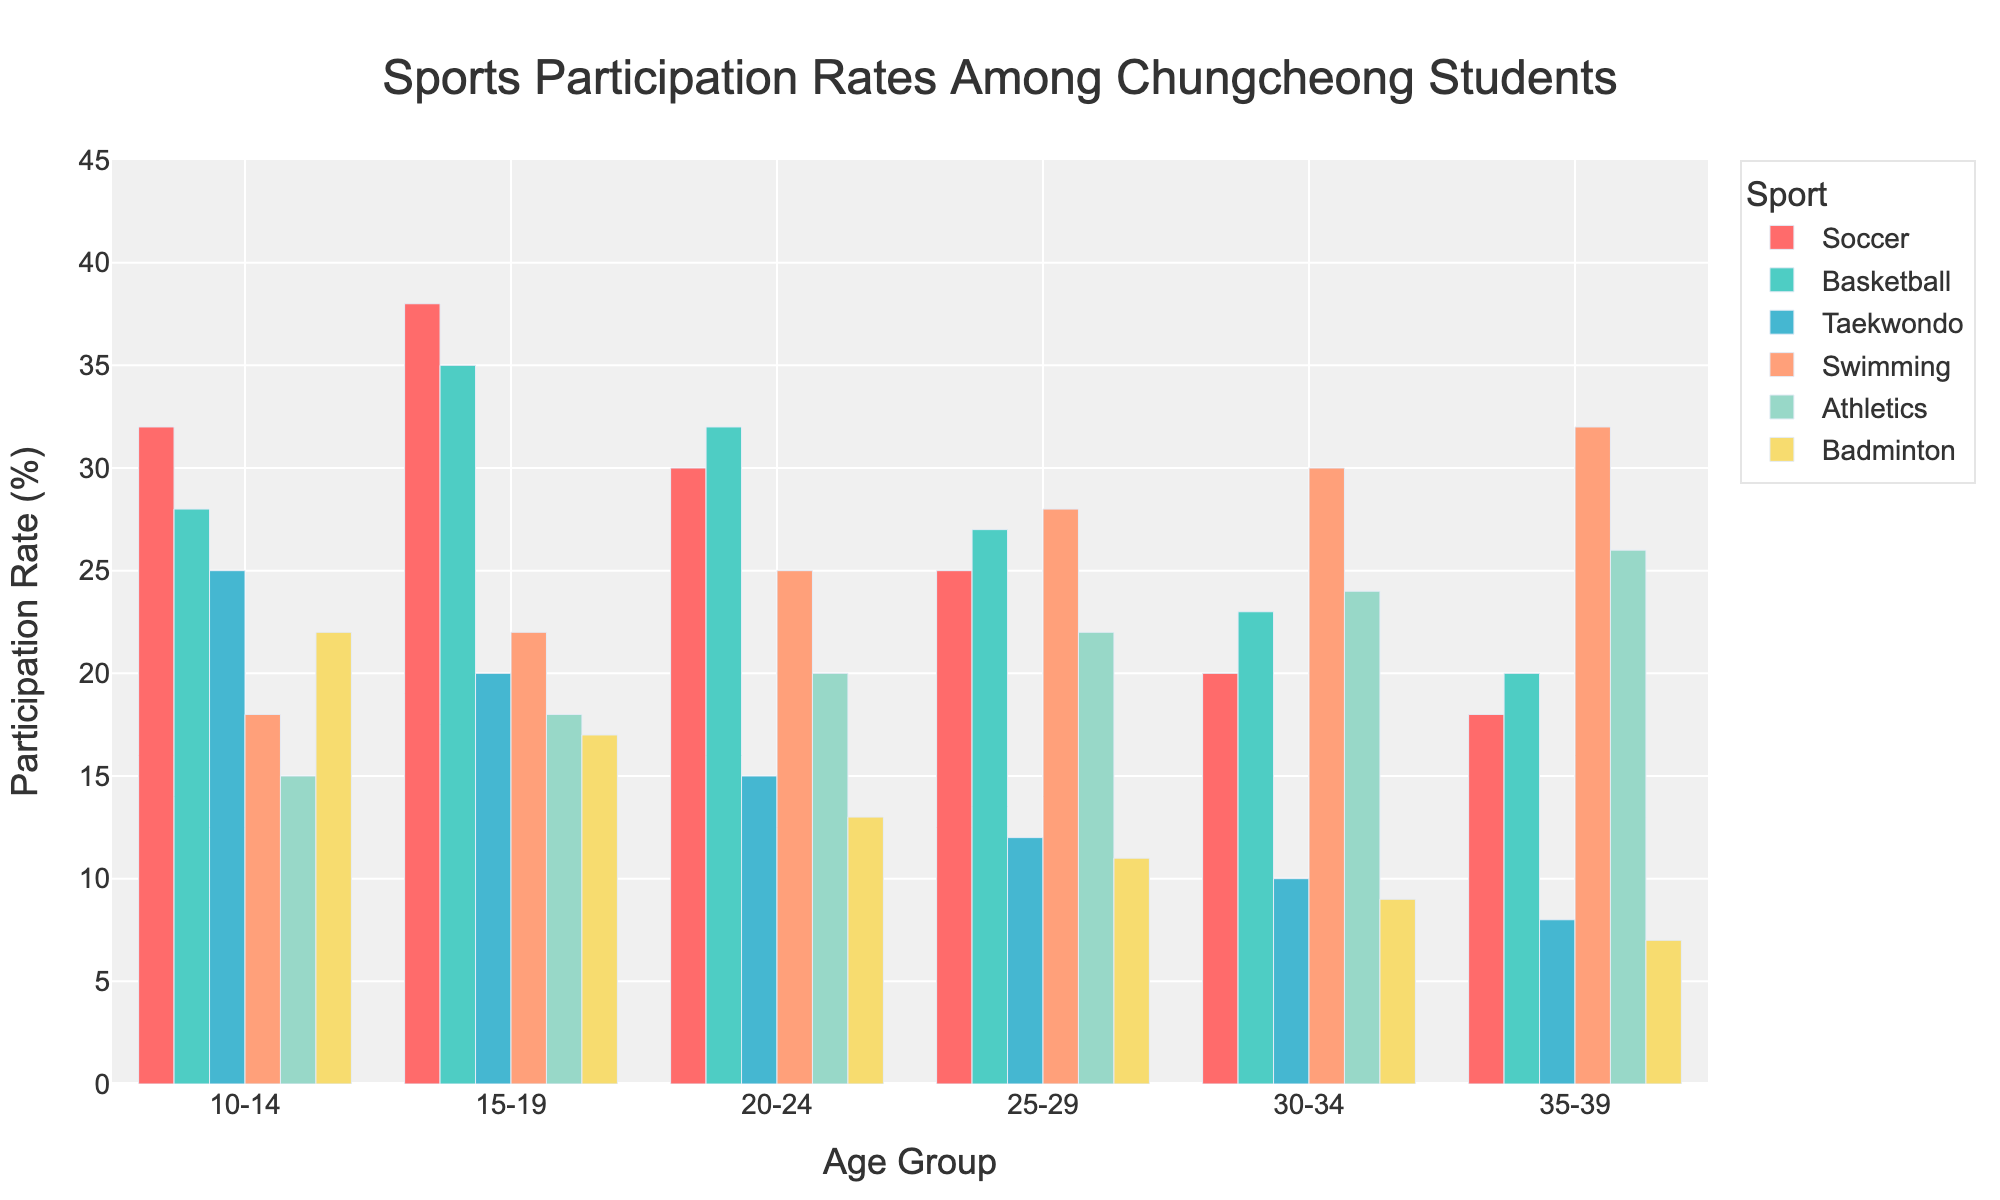Which sport has the highest participation rate among the 15-19 age group? By observing the highest bar in the 15-19 age group cluster, we notice that Soccer has the highest participation rate. The Soccer bar is the tallest one in this group.
Answer: Soccer What is the total participation rate for Swimming across all age groups? We need to sum the participation rates for Swimming from each age group: 18 (10-14) + 22 (15-19) + 25 (20-24) + 28 (25-29) + 30 (30-34) + 32 (35-39). The total is 18 + 22 + 25 + 28 + 30 + 32 = 155.
Answer: 155 Which age group has the lowest participation rate in Taekwondo? By comparing the height of the Taekwondo bars across all age groups, we see that the age group 35-39 has the lowest participation rate, as the bar for Taekwondo in this group is the shortest.
Answer: 35-39 How much higher is the participation rate in Soccer for the 15-19 age group compared to the 10-14 age group? The Soccer participation rates are 38% for the 15-19 age group and 32% for the 10-14 age group. We find the difference by subtracting: 38 - 32 = 6.
Answer: 6 In which age group does Swimming have the highest participation rate? By identifying the tallest bar for Swimming among the age groups, we find that the 35-39 age group has the highest participation rate in Swimming.
Answer: 35-39 What is the average participation rate for Badminton across all age groups? To find the average, we sum the participation rates for Badminton: 22 (10-14) + 17 (15-19) + 13 (20-24) + 11 (25-29) + 9 (30-34) + 7 (35-39). The total is 22 + 17 + 13 + 11 + 9 + 7 = 79. Then, divide by the number of age groups (6): 79 / 6 = ~13.17.
Answer: ~13.17 Does any age group have a higher participation rate in Athletics than in Soccer? We need to compare the bars for Athletics and Soccer within each age group. None of the age groups have a higher participation rate for Athletics compared to Soccer.
Answer: No 